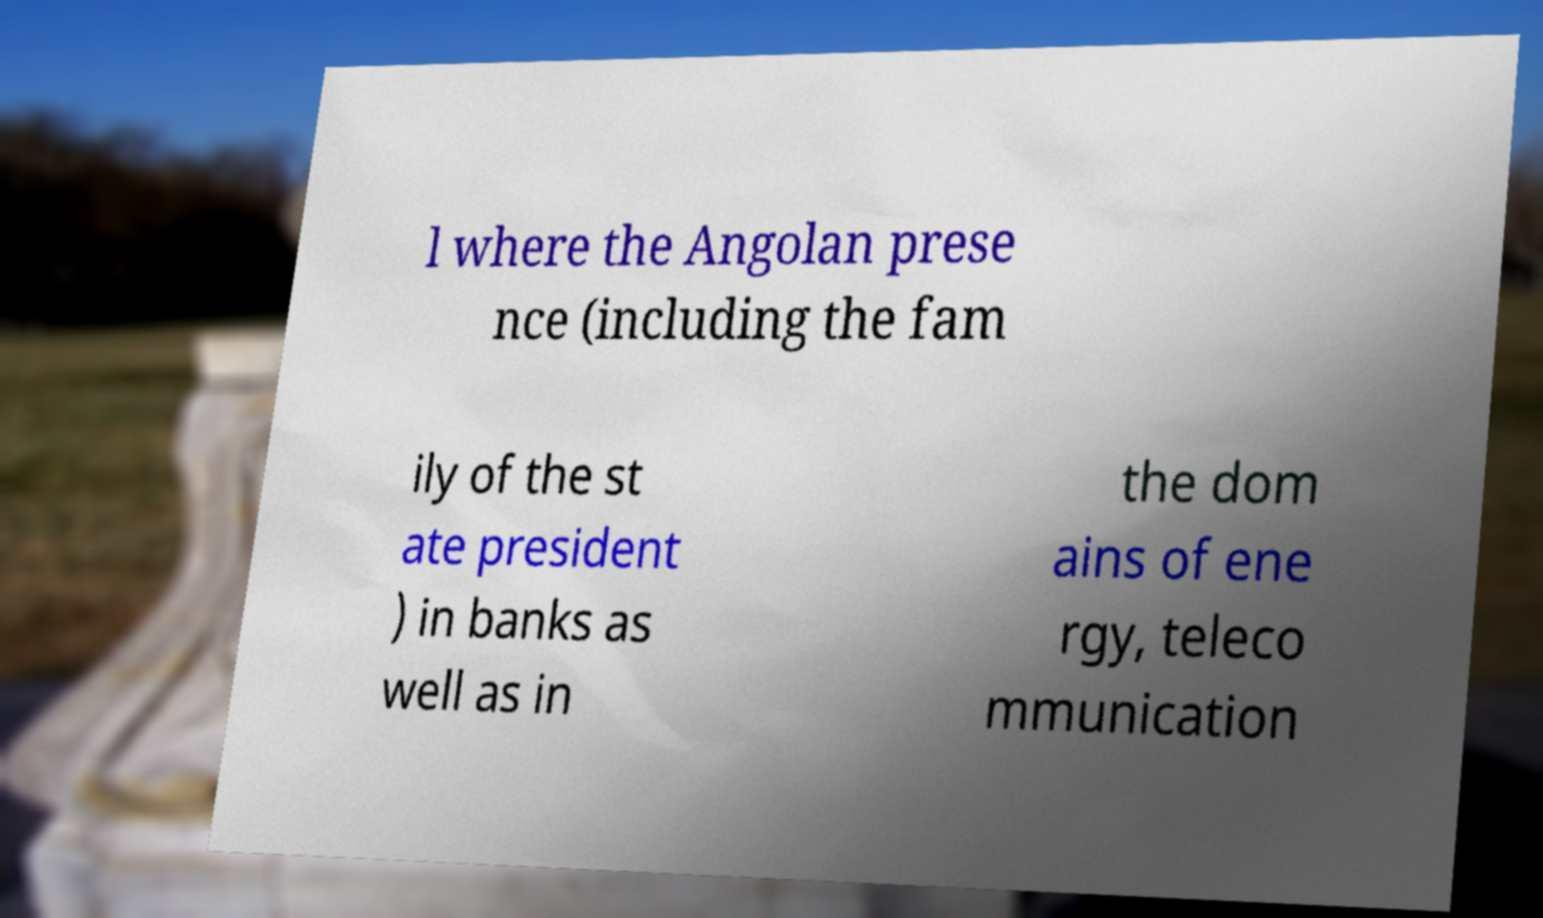There's text embedded in this image that I need extracted. Can you transcribe it verbatim? l where the Angolan prese nce (including the fam ily of the st ate president ) in banks as well as in the dom ains of ene rgy, teleco mmunication 